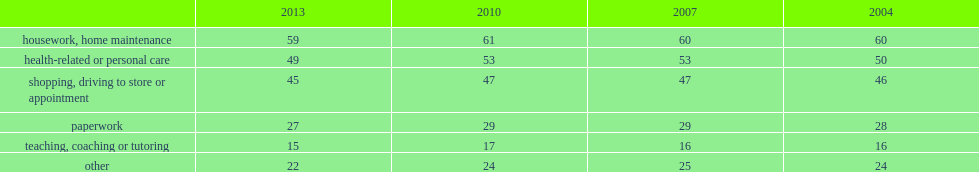How many percentage points do health-related and personal care support drop since 2010 to 2013? 4. 